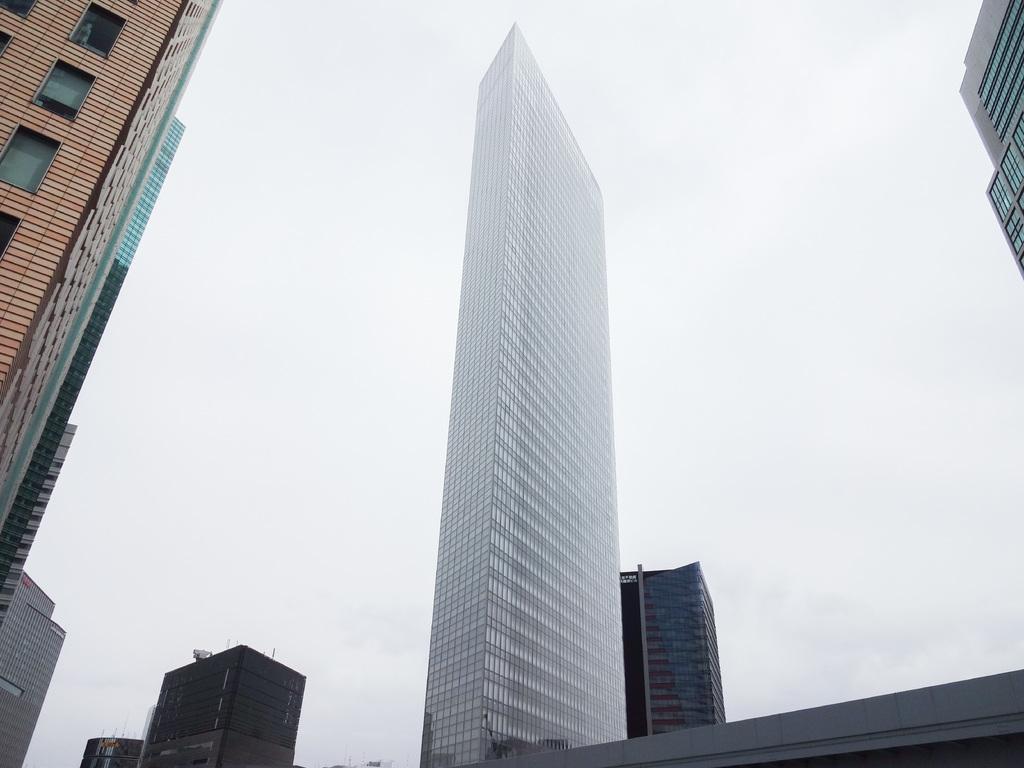Please provide a concise description of this image. In this image there are buildings and the sky is cloudy. 